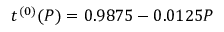Convert formula to latex. <formula><loc_0><loc_0><loc_500><loc_500>t ^ { ( 0 ) } ( P ) = 0 . 9 8 7 5 - 0 . 0 1 2 5 P</formula> 